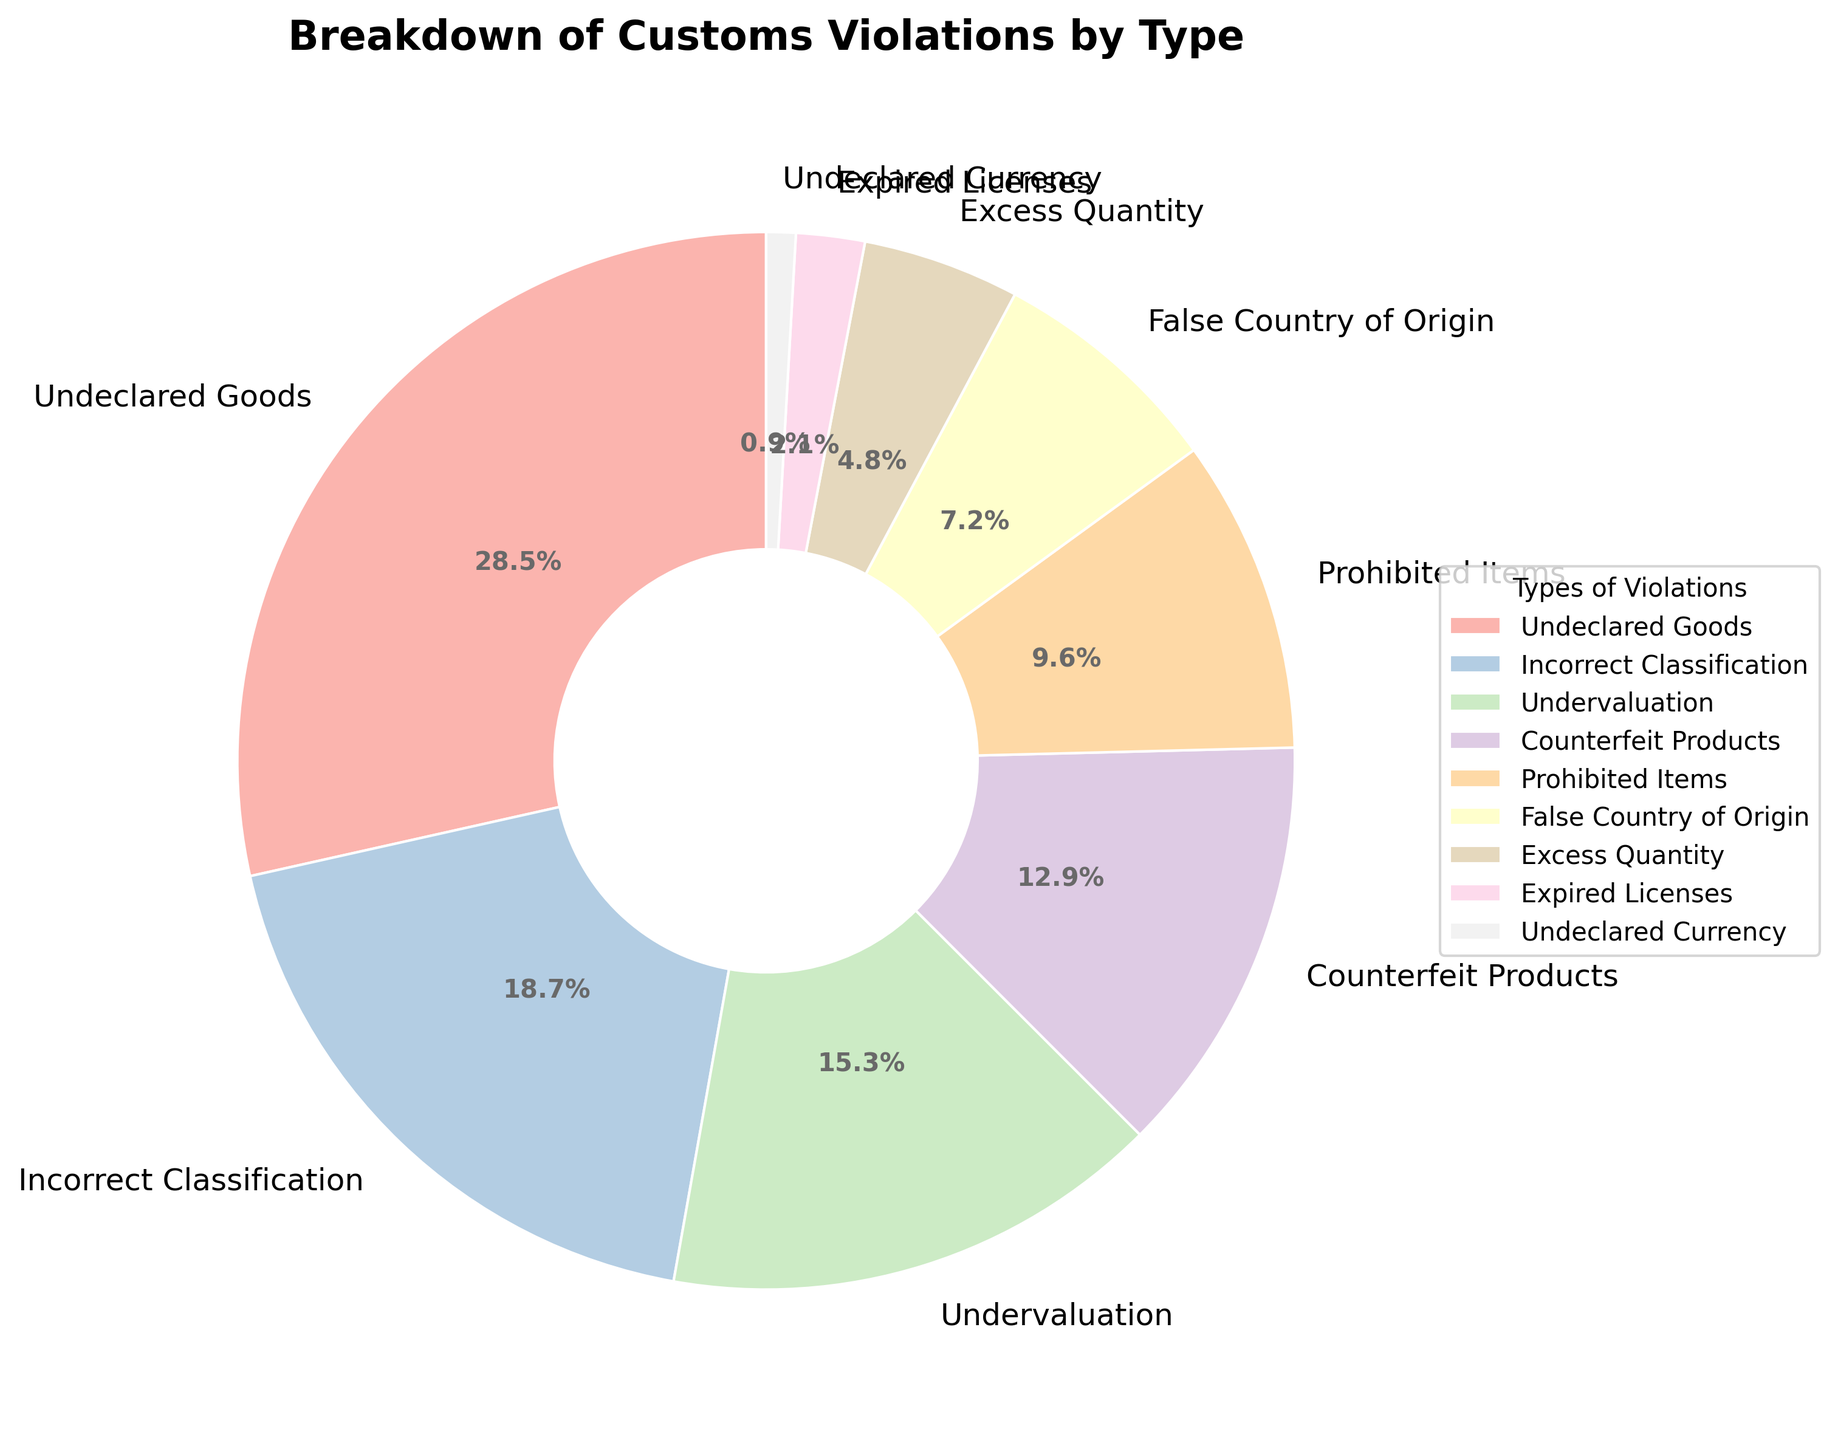What percentage of violations are due to Undeclared Goods? Locate the segment of the pie chart labeled 'Undeclared Goods'. The percentage is given next to the label.
Answer: 28.5% Which type of violation is the least common? The smallest segment in the pie chart represents the least common violation, labeled 'Undeclared Currency'.
Answer: Undeclared Currency How much more common are Undeclared Goods violations compared to Expired Licenses violations? Find the percentages for both 'Undeclared Goods' (28.5%) and 'Expired Licenses' (2.1%). Subtract the percentage of 'Expired Licenses' from 'Undeclared Goods': 28.5 - 2.1.
Answer: 26.4% Which types of violations make up more than 10% each? Identify the segments in the pie chart where the percentage is greater than 10%. These segments are 'Undeclared Goods', 'Incorrect Classification', and 'Undervaluation'.
Answer: Undeclared Goods, Incorrect Classification, Undervaluation What is the combined percentage of violations for Counterfeit Products and Prohibited Items? Find the percentages for 'Counterfeit Products' (12.9%) and 'Prohibited Items' (9.6%). Add these percentages together: 12.9 + 9.6.
Answer: 22.5% Are there more Incorrect Classification violations or Undervaluation violations? Compare the percentages of 'Incorrect Classification' (18.7%) and 'Undervaluation' (15.3%). 'Incorrect Classification' has a higher percentage.
Answer: Incorrect Classification When compared to False Country of Origin violations, are Prohibited Items violations more or less frequent? Compare the percentages for 'Prohibited Items' (9.6%) and 'False Country of Origin' (7.2%). 'Prohibited Items' has a higher percentage.
Answer: More frequent Which type of violation represented in the pie chart uses the darkest color? Look for the segment with the darkest shade in the pie chart. In general, colors are mapped along the gradient from Pastel1 color palette; check visually which is the darkest. The segment for 'Undeclared Goods' appears to be the darkest.
Answer: Undeclared Goods What percentage of the violations are accounted for by Undeclared Goods, Incorrect Classification, and Undervaluation combined? Sum the percentages of 'Undeclared Goods' (28.5%), 'Incorrect Classification' (18.7%), and 'Undervaluation' (15.3%). The calculation is: 28.5 + 18.7 + 15.3.
Answer: 62.5% What visual attribute helps to easily differentiate between types of violations in the pie chart? Mention the visual attribute that is used to distinguish between different categories in the pie chart. Each type of violation is represented by different colors.
Answer: Colors 